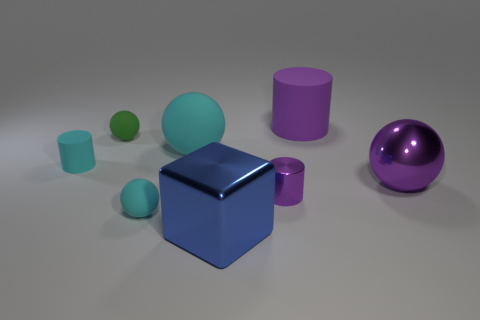Does the large thing that is to the left of the blue metal object have the same material as the ball behind the big cyan matte ball? While I can certainly compare the visual aspects of the objects in the image, determining the exact material strictly from a visual standpoint is challenging without additional context or information. However, based on the visual cues, the large object to the left of the blue metal-looking cube appears to have a similar reflective surface as the purple ball behind the bigger matte cyan sphere, which suggests they could be made of similar materials, possibly a type of polished metal or plastic with a reflective coating. 